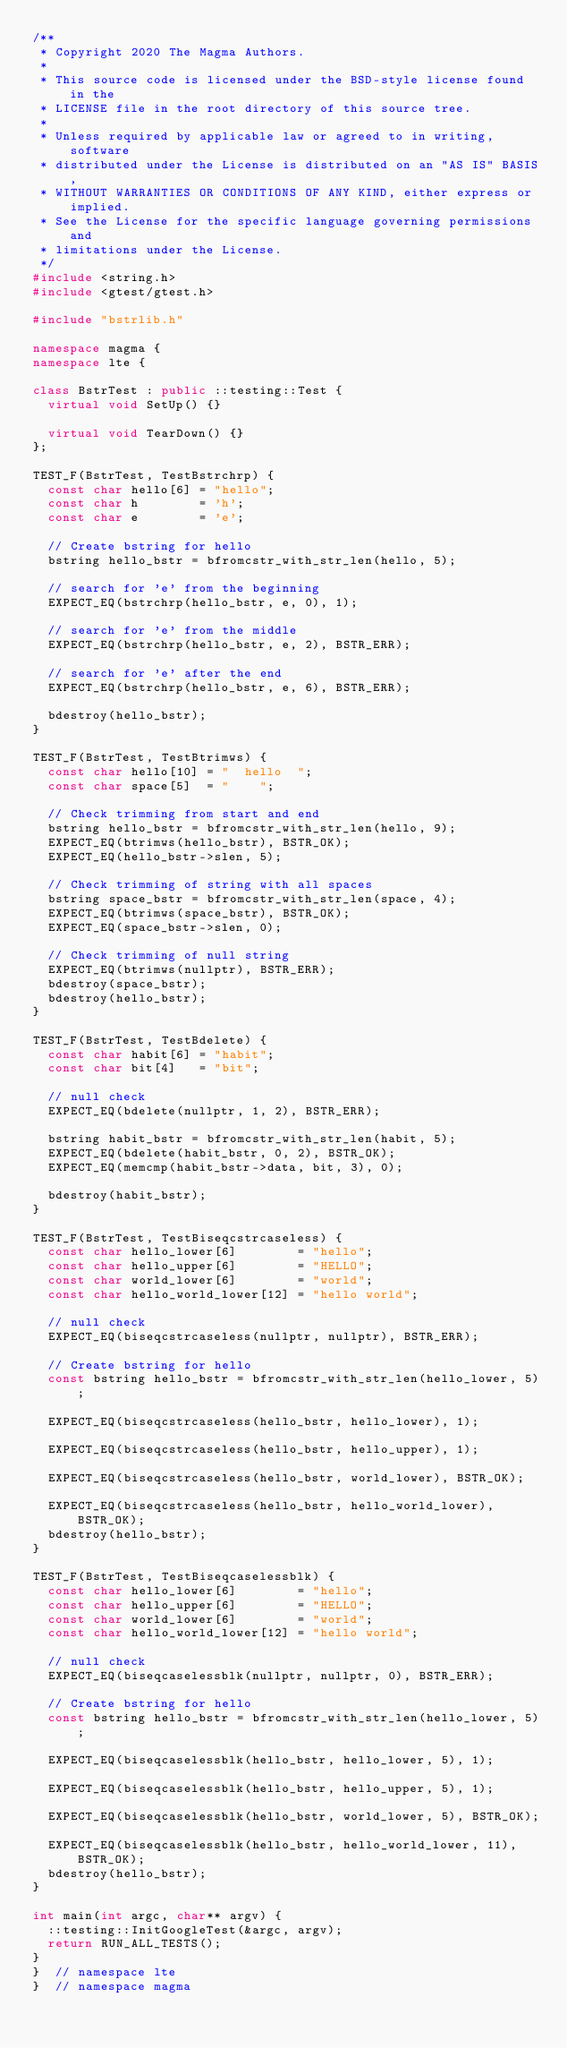Convert code to text. <code><loc_0><loc_0><loc_500><loc_500><_C++_>/**
 * Copyright 2020 The Magma Authors.
 *
 * This source code is licensed under the BSD-style license found in the
 * LICENSE file in the root directory of this source tree.
 *
 * Unless required by applicable law or agreed to in writing, software
 * distributed under the License is distributed on an "AS IS" BASIS,
 * WITHOUT WARRANTIES OR CONDITIONS OF ANY KIND, either express or implied.
 * See the License for the specific language governing permissions and
 * limitations under the License.
 */
#include <string.h>
#include <gtest/gtest.h>

#include "bstrlib.h"

namespace magma {
namespace lte {

class BstrTest : public ::testing::Test {
  virtual void SetUp() {}

  virtual void TearDown() {}
};

TEST_F(BstrTest, TestBstrchrp) {
  const char hello[6] = "hello";
  const char h        = 'h';
  const char e        = 'e';

  // Create bstring for hello
  bstring hello_bstr = bfromcstr_with_str_len(hello, 5);

  // search for 'e' from the beginning
  EXPECT_EQ(bstrchrp(hello_bstr, e, 0), 1);

  // search for 'e' from the middle
  EXPECT_EQ(bstrchrp(hello_bstr, e, 2), BSTR_ERR);

  // search for 'e' after the end
  EXPECT_EQ(bstrchrp(hello_bstr, e, 6), BSTR_ERR);

  bdestroy(hello_bstr);
}

TEST_F(BstrTest, TestBtrimws) {
  const char hello[10] = "  hello  ";
  const char space[5]  = "    ";

  // Check trimming from start and end
  bstring hello_bstr = bfromcstr_with_str_len(hello, 9);
  EXPECT_EQ(btrimws(hello_bstr), BSTR_OK);
  EXPECT_EQ(hello_bstr->slen, 5);

  // Check trimming of string with all spaces
  bstring space_bstr = bfromcstr_with_str_len(space, 4);
  EXPECT_EQ(btrimws(space_bstr), BSTR_OK);
  EXPECT_EQ(space_bstr->slen, 0);

  // Check trimming of null string
  EXPECT_EQ(btrimws(nullptr), BSTR_ERR);
  bdestroy(space_bstr);
  bdestroy(hello_bstr);
}

TEST_F(BstrTest, TestBdelete) {
  const char habit[6] = "habit";
  const char bit[4]   = "bit";

  // null check
  EXPECT_EQ(bdelete(nullptr, 1, 2), BSTR_ERR);

  bstring habit_bstr = bfromcstr_with_str_len(habit, 5);
  EXPECT_EQ(bdelete(habit_bstr, 0, 2), BSTR_OK);
  EXPECT_EQ(memcmp(habit_bstr->data, bit, 3), 0);

  bdestroy(habit_bstr);
}

TEST_F(BstrTest, TestBiseqcstrcaseless) {
  const char hello_lower[6]        = "hello";
  const char hello_upper[6]        = "HELLO";
  const char world_lower[6]        = "world";
  const char hello_world_lower[12] = "hello world";

  // null check
  EXPECT_EQ(biseqcstrcaseless(nullptr, nullptr), BSTR_ERR);

  // Create bstring for hello
  const bstring hello_bstr = bfromcstr_with_str_len(hello_lower, 5);

  EXPECT_EQ(biseqcstrcaseless(hello_bstr, hello_lower), 1);

  EXPECT_EQ(biseqcstrcaseless(hello_bstr, hello_upper), 1);

  EXPECT_EQ(biseqcstrcaseless(hello_bstr, world_lower), BSTR_OK);

  EXPECT_EQ(biseqcstrcaseless(hello_bstr, hello_world_lower), BSTR_OK);
  bdestroy(hello_bstr);
}

TEST_F(BstrTest, TestBiseqcaselessblk) {
  const char hello_lower[6]        = "hello";
  const char hello_upper[6]        = "HELLO";
  const char world_lower[6]        = "world";
  const char hello_world_lower[12] = "hello world";

  // null check
  EXPECT_EQ(biseqcaselessblk(nullptr, nullptr, 0), BSTR_ERR);

  // Create bstring for hello
  const bstring hello_bstr = bfromcstr_with_str_len(hello_lower, 5);

  EXPECT_EQ(biseqcaselessblk(hello_bstr, hello_lower, 5), 1);

  EXPECT_EQ(biseqcaselessblk(hello_bstr, hello_upper, 5), 1);

  EXPECT_EQ(biseqcaselessblk(hello_bstr, world_lower, 5), BSTR_OK);

  EXPECT_EQ(biseqcaselessblk(hello_bstr, hello_world_lower, 11), BSTR_OK);
  bdestroy(hello_bstr);
}

int main(int argc, char** argv) {
  ::testing::InitGoogleTest(&argc, argv);
  return RUN_ALL_TESTS();
}
}  // namespace lte
}  // namespace magma
</code> 